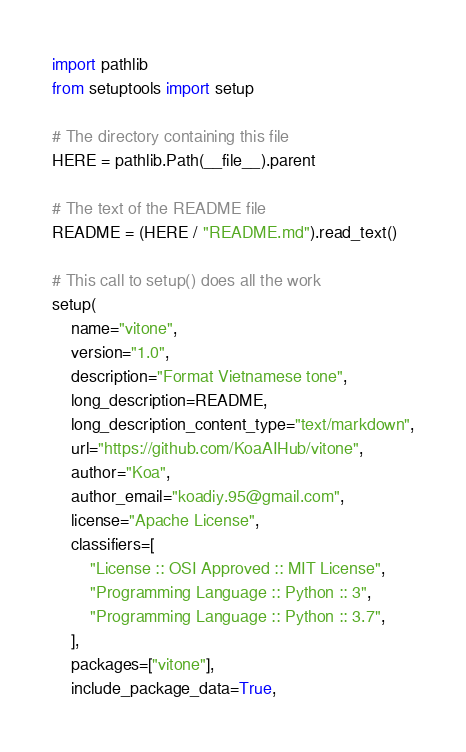Convert code to text. <code><loc_0><loc_0><loc_500><loc_500><_Python_>import pathlib
from setuptools import setup

# The directory containing this file
HERE = pathlib.Path(__file__).parent

# The text of the README file
README = (HERE / "README.md").read_text()

# This call to setup() does all the work
setup(
    name="vitone",
    version="1.0",
    description="Format Vietnamese tone",
    long_description=README,
    long_description_content_type="text/markdown",
    url="https://github.com/KoaAIHub/vitone",
    author="Koa",
    author_email="koadiy.95@gmail.com",
    license="Apache License",
    classifiers=[
        "License :: OSI Approved :: MIT License",
        "Programming Language :: Python :: 3",
        "Programming Language :: Python :: 3.7",
    ],
    packages=["vitone"],
    include_package_data=True,</code> 